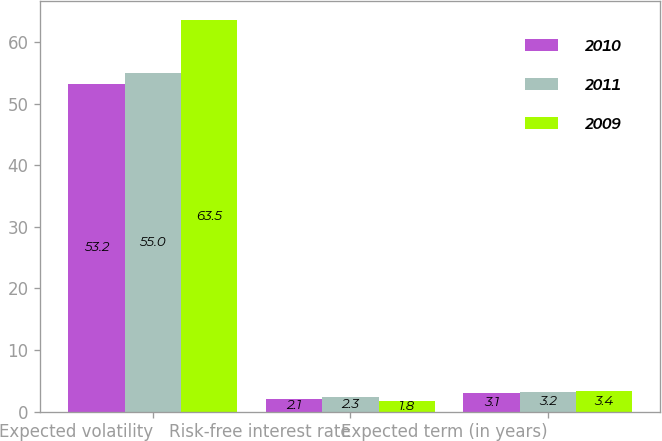Convert chart to OTSL. <chart><loc_0><loc_0><loc_500><loc_500><stacked_bar_chart><ecel><fcel>Expected volatility<fcel>Risk-free interest rate<fcel>Expected term (in years)<nl><fcel>2010<fcel>53.2<fcel>2.1<fcel>3.1<nl><fcel>2011<fcel>55<fcel>2.3<fcel>3.2<nl><fcel>2009<fcel>63.5<fcel>1.8<fcel>3.4<nl></chart> 